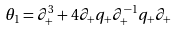Convert formula to latex. <formula><loc_0><loc_0><loc_500><loc_500>\theta _ { 1 } = \partial _ { + } ^ { 3 } + 4 \partial _ { + } q _ { + } \partial _ { + } ^ { - 1 } q _ { + } \partial _ { + }</formula> 